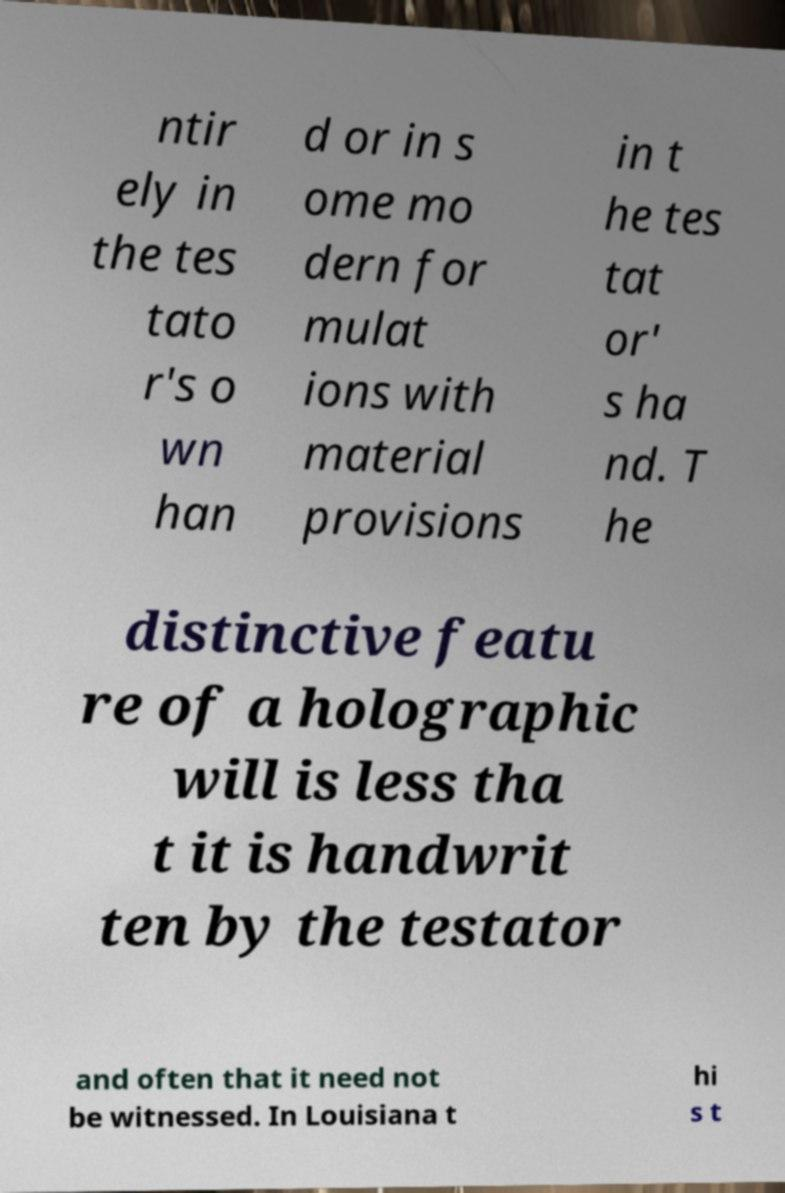Could you assist in decoding the text presented in this image and type it out clearly? ntir ely in the tes tato r's o wn han d or in s ome mo dern for mulat ions with material provisions in t he tes tat or' s ha nd. T he distinctive featu re of a holographic will is less tha t it is handwrit ten by the testator and often that it need not be witnessed. In Louisiana t hi s t 